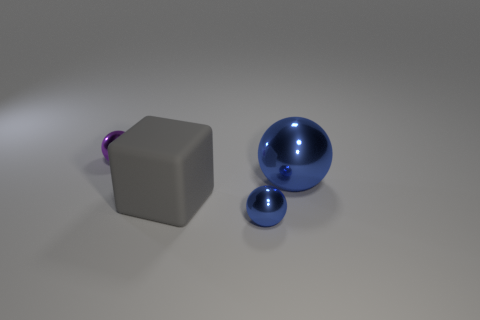Add 3 spheres. How many objects exist? 7 Subtract all spheres. How many objects are left? 1 Subtract 0 brown cubes. How many objects are left? 4 Subtract all big gray blocks. Subtract all big objects. How many objects are left? 1 Add 2 large matte cubes. How many large matte cubes are left? 3 Add 2 big yellow objects. How many big yellow objects exist? 2 